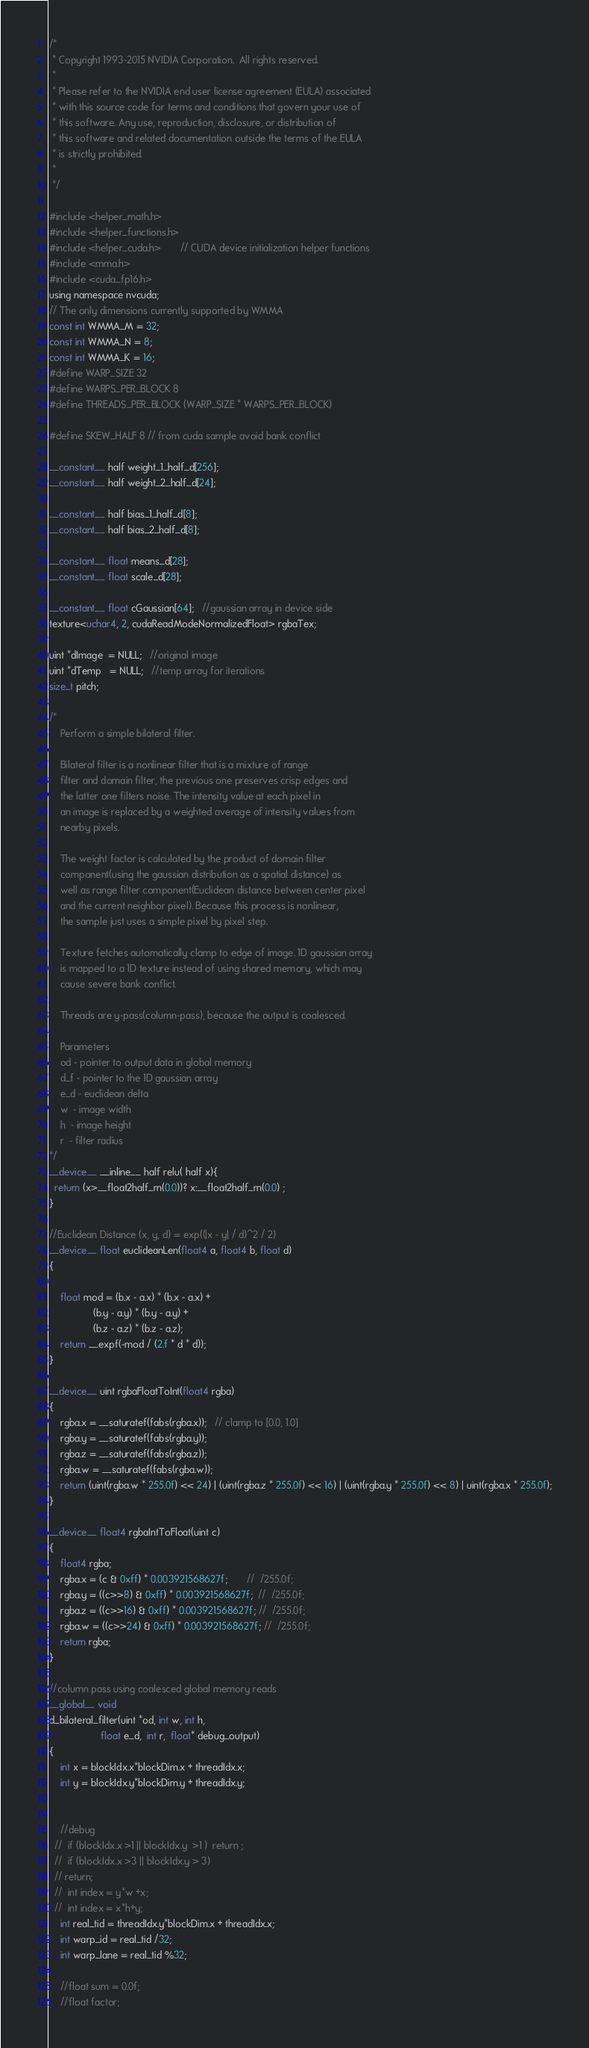<code> <loc_0><loc_0><loc_500><loc_500><_Cuda_>/*
 * Copyright 1993-2015 NVIDIA Corporation.  All rights reserved.
 *
 * Please refer to the NVIDIA end user license agreement (EULA) associated
 * with this source code for terms and conditions that govern your use of
 * this software. Any use, reproduction, disclosure, or distribution of
 * this software and related documentation outside the terms of the EULA
 * is strictly prohibited.
 *
 */

#include <helper_math.h>
#include <helper_functions.h>
#include <helper_cuda.h>       // CUDA device initialization helper functions
#include <mma.h>
#include <cuda_fp16.h>
using namespace nvcuda;
// The only dimensions currently supported by WMMA
const int WMMA_M = 32;
const int WMMA_N = 8;
const int WMMA_K = 16;
#define WARP_SIZE 32
#define WARPS_PER_BLOCK 8
#define THREADS_PER_BLOCK (WARP_SIZE * WARPS_PER_BLOCK)

#define SKEW_HALF 8 // from cuda sample avoid bank conflict

__constant__ half weight_1_half_d[256];
__constant__ half weight_2_half_d[24];

__constant__ half bias_1_half_d[8];
__constant__ half bias_2_half_d[8];

__constant__ float means_d[28];
__constant__ float scale_d[28];

__constant__ float cGaussian[64];   //gaussian array in device side
texture<uchar4, 2, cudaReadModeNormalizedFloat> rgbaTex;

uint *dImage  = NULL;   //original image
uint *dTemp   = NULL;   //temp array for iterations
size_t pitch;

/*
    Perform a simple bilateral filter.

    Bilateral filter is a nonlinear filter that is a mixture of range
    filter and domain filter, the previous one preserves crisp edges and
    the latter one filters noise. The intensity value at each pixel in
    an image is replaced by a weighted average of intensity values from
    nearby pixels.

    The weight factor is calculated by the product of domain filter
    component(using the gaussian distribution as a spatial distance) as
    well as range filter component(Euclidean distance between center pixel
    and the current neighbor pixel). Because this process is nonlinear,
    the sample just uses a simple pixel by pixel step.

    Texture fetches automatically clamp to edge of image. 1D gaussian array
    is mapped to a 1D texture instead of using shared memory, which may
    cause severe bank conflict.

    Threads are y-pass(column-pass), because the output is coalesced.

    Parameters
    od - pointer to output data in global memory
    d_f - pointer to the 1D gaussian array
    e_d - euclidean delta
    w  - image width
    h  - image height
    r  - filter radius
*/
__device__ __inline__ half relu( half x){
  return (x>__float2half_rn(0.0))? x:__float2half_rn(0.0) ;
}

//Euclidean Distance (x, y, d) = exp((|x - y| / d)^2 / 2)
__device__ float euclideanLen(float4 a, float4 b, float d)
{

    float mod = (b.x - a.x) * (b.x - a.x) +
                (b.y - a.y) * (b.y - a.y) +
                (b.z - a.z) * (b.z - a.z);
    return __expf(-mod / (2.f * d * d));
}

__device__ uint rgbaFloatToInt(float4 rgba)
{
    rgba.x = __saturatef(fabs(rgba.x));   // clamp to [0.0, 1.0]
    rgba.y = __saturatef(fabs(rgba.y));
    rgba.z = __saturatef(fabs(rgba.z));
    rgba.w = __saturatef(fabs(rgba.w));
    return (uint(rgba.w * 255.0f) << 24) | (uint(rgba.z * 255.0f) << 16) | (uint(rgba.y * 255.0f) << 8) | uint(rgba.x * 255.0f);
}

__device__ float4 rgbaIntToFloat(uint c)
{
    float4 rgba;
    rgba.x = (c & 0xff) * 0.003921568627f;       //  /255.0f;
    rgba.y = ((c>>8) & 0xff) * 0.003921568627f;  //  /255.0f;
    rgba.z = ((c>>16) & 0xff) * 0.003921568627f; //  /255.0f;
    rgba.w = ((c>>24) & 0xff) * 0.003921568627f; //  /255.0f;
    return rgba;
}

//column pass using coalesced global memory reads
__global__ void
d_bilateral_filter(uint *od, int w, int h,
                   float e_d,  int r,  float* debug_output)
{
    int x = blockIdx.x*blockDim.x + threadIdx.x;
    int y = blockIdx.y*blockDim.y + threadIdx.y;


    //debug
  //  if (blockIdx.x >1 || blockIdx.y  >1 )  return ;
  //  if (blockIdx.x >3 || blockIdx.y > 3)
  // return;
  //  int index = y*w +x;
  //  int index = x*h+y;
    int real_tid = threadIdx.y*blockDim.x + threadIdx.x;
    int warp_id = real_tid /32;
    int warp_lane = real_tid %32;

    //float sum = 0.0f;
    //float factor;</code> 